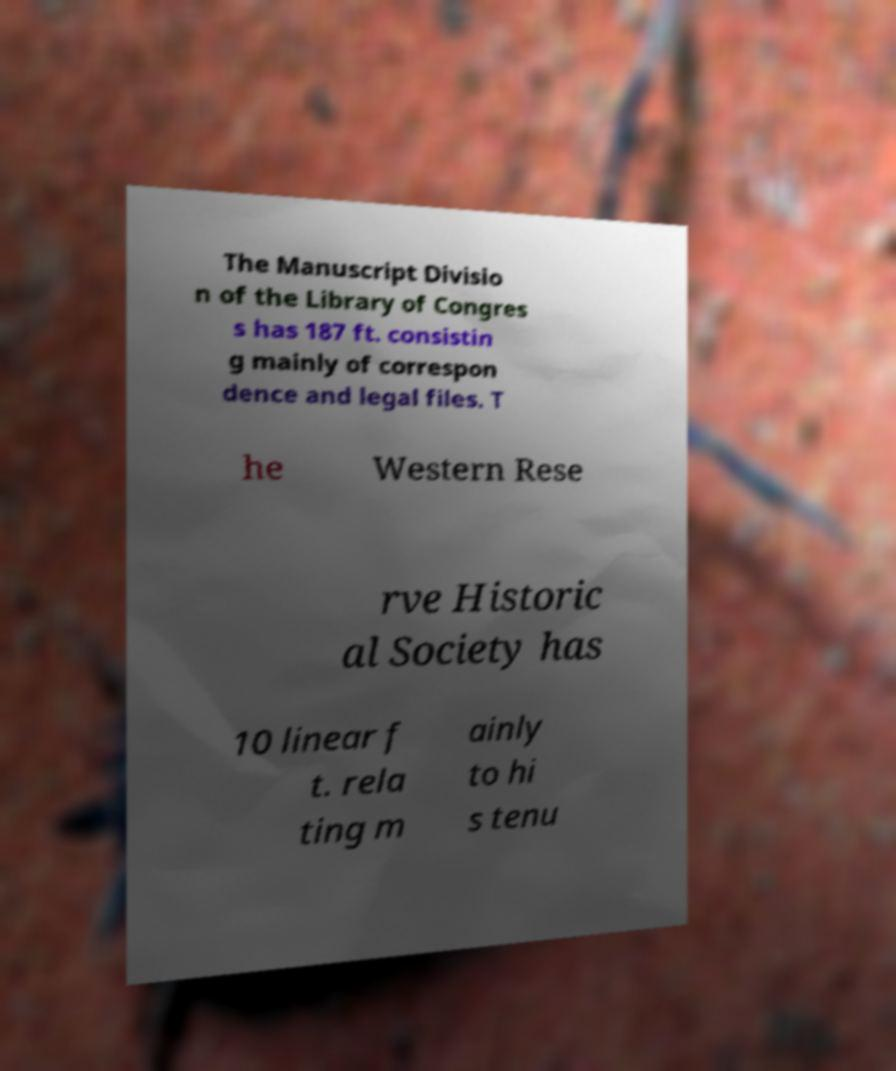There's text embedded in this image that I need extracted. Can you transcribe it verbatim? The Manuscript Divisio n of the Library of Congres s has 187 ft. consistin g mainly of correspon dence and legal files. T he Western Rese rve Historic al Society has 10 linear f t. rela ting m ainly to hi s tenu 